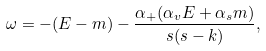<formula> <loc_0><loc_0><loc_500><loc_500>\omega = - ( E - m ) - \frac { \alpha _ { + } ( \alpha _ { v } E + \alpha _ { s } m ) } { s ( s - k ) } ,</formula> 